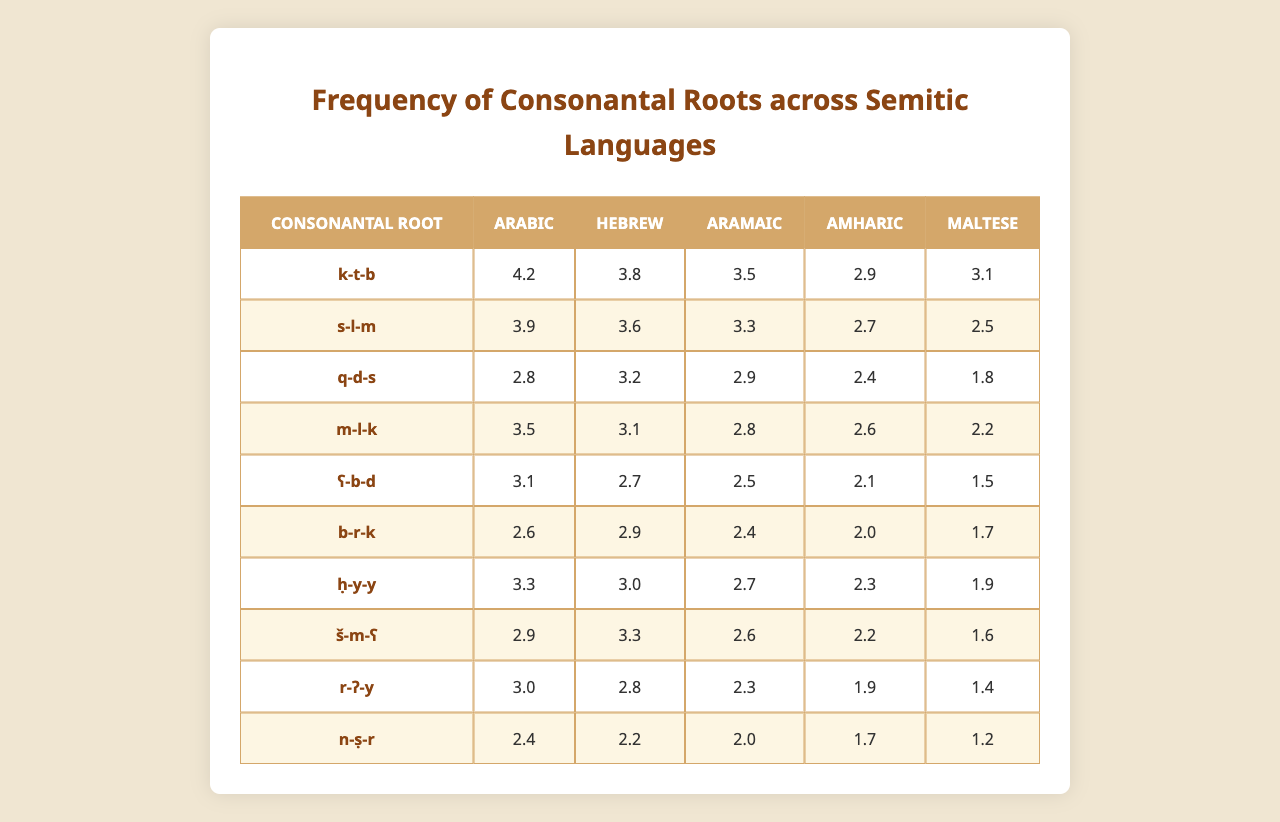What is the frequency of the consonantal root "k-t-b" in Arabic? The table lists "k-t-b" with a frequency of 4.2 for Arabic.
Answer: 4.2 Which Semitic language has the highest frequency for the root "s-l-m"? The root "s-l-m" has its highest frequency in Arabic with a value of 3.9.
Answer: Arabic Is the frequency of the root "m-l-k" higher in Hebrew or Aramaic? The table shows that "m-l-k" has a frequency of 3.1 in Hebrew and 2.8 in Aramaic, so Hebrew has a higher frequency.
Answer: Yes What is the average frequency of the root "ħ-y-y" across the listed Semitic languages? The frequencies for "ħ-y-y" are 3.3 (Arabic), 3.0 (Hebrew), 2.7 (Aramaic), 2.3 (Amharic), and 1.9 (Maltese). Summing these gives 3.3 + 3.0 + 2.7 + 2.3 + 1.9 = 13.2, and dividing by 5 gives an average of 2.64.
Answer: 2.64 Which consonantal root has the lowest frequency in Maltese? Checking the Maltese column, "q-d-s" has the lowest value at 1.8.
Answer: q-d-s What is the total frequency of the root "b-r-k" across all languages? The frequencies for "b-r-k" are 2.6 (Arabic), 2.9 (Hebrew), 2.4 (Aramaic), 2.0 (Amharic), and 1.7 (Maltese). Summing these gives 2.6 + 2.9 + 2.4 + 2.0 + 1.7 = 11.6.
Answer: 11.6 Which root appears to be the least common in Amharic compared to its representation in other languages? The root "ʕ-b-d" has the lowest frequency (2.1) in Amharic compared to the other frequencies listed for that root across languages.
Answer: ʕ-b-d How many roots have a higher frequency in Arabic than in Hebrew? The roots k-t-b, s-l-m, ḥ-y-y, and r-ʔ-y have higher frequencies in Arabic than in Hebrew, making a total of 4 roots.
Answer: 4 Which root has a frequency of 3.5 in Aramaic? Referring to the table, the root "k-t-b" has a frequency of 3.5 in Aramaic.
Answer: k-t-b What is the difference in frequency of the root "n-ṣ-r" between Hebrew and Maltese? The frequency for "n-ṣ-r" is 2.2 in Hebrew and 1.2 in Maltese. The difference is 2.2 - 1.2 = 1.0.
Answer: 1.0 Are there any roots where the frequency in Hebrew is the same or higher than in all other languages listed? Yes, the root "s-l-m" has a frequency of 3.6 in Hebrew, which is equal to or higher than the frequencies in all other languages listed for that root.
Answer: Yes 